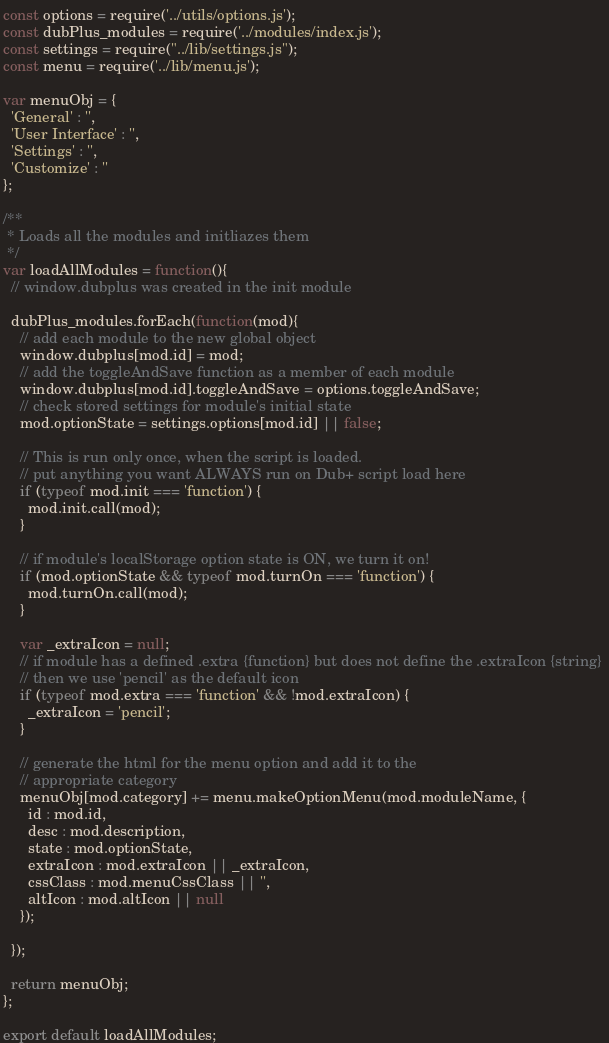Convert code to text. <code><loc_0><loc_0><loc_500><loc_500><_JavaScript_>const options = require('../utils/options.js');
const dubPlus_modules = require('../modules/index.js');
const settings = require("../lib/settings.js");
const menu = require('../lib/menu.js');

var menuObj = {
  'General' : '',
  'User Interface' : '',
  'Settings' : '',
  'Customize' : ''
};

/**
 * Loads all the modules and initliazes them
 */
var loadAllModules = function(){
  // window.dubplus was created in the init module

  dubPlus_modules.forEach(function(mod){
    // add each module to the new global object
    window.dubplus[mod.id] = mod;
    // add the toggleAndSave function as a member of each module
    window.dubplus[mod.id].toggleAndSave = options.toggleAndSave;
    // check stored settings for module's initial state
    mod.optionState = settings.options[mod.id] || false;
    
    // This is run only once, when the script is loaded.
    // put anything you want ALWAYS run on Dub+ script load here 
    if (typeof mod.init === 'function') { 
      mod.init.call(mod); 
    }

    // if module's localStorage option state is ON, we turn it on!
    if (mod.optionState && typeof mod.turnOn === 'function') {
      mod.turnOn.call(mod);
    }

    var _extraIcon = null;
    // if module has a defined .extra {function} but does not define the .extraIcon {string} 
    // then we use 'pencil' as the default icon
    if (typeof mod.extra === 'function' && !mod.extraIcon) {
      _extraIcon = 'pencil';
    }

    // generate the html for the menu option and add it to the
    // appropriate category
    menuObj[mod.category] += menu.makeOptionMenu(mod.moduleName, {
      id : mod.id,
      desc : mod.description,
      state : mod.optionState,
      extraIcon : mod.extraIcon || _extraIcon,
      cssClass : mod.menuCssClass || '',
      altIcon : mod.altIcon || null
    });

  });

  return menuObj;
};

export default loadAllModules;</code> 